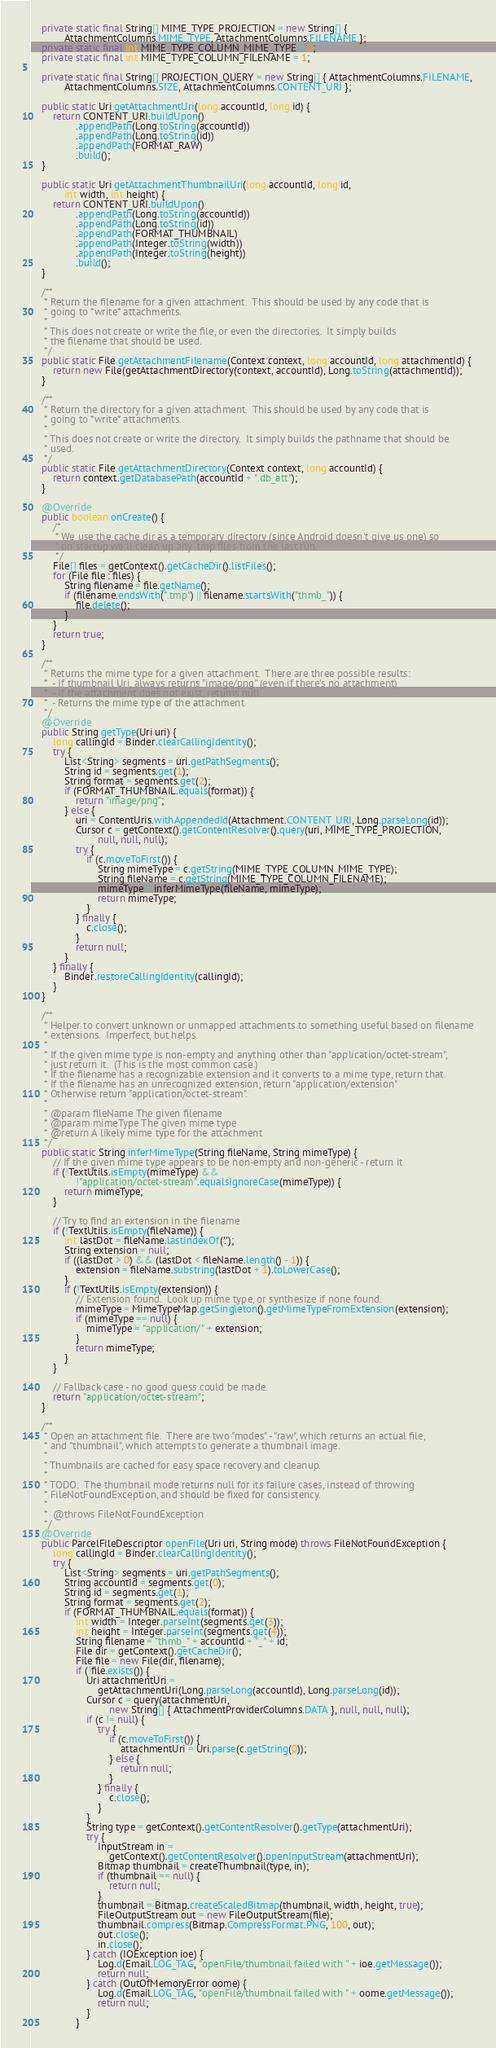<code> <loc_0><loc_0><loc_500><loc_500><_Java_>
    private static final String[] MIME_TYPE_PROJECTION = new String[] {
            AttachmentColumns.MIME_TYPE, AttachmentColumns.FILENAME };
    private static final int MIME_TYPE_COLUMN_MIME_TYPE = 0;
    private static final int MIME_TYPE_COLUMN_FILENAME = 1;

    private static final String[] PROJECTION_QUERY = new String[] { AttachmentColumns.FILENAME,
            AttachmentColumns.SIZE, AttachmentColumns.CONTENT_URI };

    public static Uri getAttachmentUri(long accountId, long id) {
        return CONTENT_URI.buildUpon()
                .appendPath(Long.toString(accountId))
                .appendPath(Long.toString(id))
                .appendPath(FORMAT_RAW)
                .build();
    }

    public static Uri getAttachmentThumbnailUri(long accountId, long id,
            int width, int height) {
        return CONTENT_URI.buildUpon()
                .appendPath(Long.toString(accountId))
                .appendPath(Long.toString(id))
                .appendPath(FORMAT_THUMBNAIL)
                .appendPath(Integer.toString(width))
                .appendPath(Integer.toString(height))
                .build();
    }

    /**
     * Return the filename for a given attachment.  This should be used by any code that is
     * going to *write* attachments.
     *
     * This does not create or write the file, or even the directories.  It simply builds
     * the filename that should be used.
     */
    public static File getAttachmentFilename(Context context, long accountId, long attachmentId) {
        return new File(getAttachmentDirectory(context, accountId), Long.toString(attachmentId));
    }

    /**
     * Return the directory for a given attachment.  This should be used by any code that is
     * going to *write* attachments.
     *
     * This does not create or write the directory.  It simply builds the pathname that should be
     * used.
     */
    public static File getAttachmentDirectory(Context context, long accountId) {
        return context.getDatabasePath(accountId + ".db_att");
    }

    @Override
    public boolean onCreate() {
        /*
         * We use the cache dir as a temporary directory (since Android doesn't give us one) so
         * on startup we'll clean up any .tmp files from the last run.
         */
        File[] files = getContext().getCacheDir().listFiles();
        for (File file : files) {
            String filename = file.getName();
            if (filename.endsWith(".tmp") || filename.startsWith("thmb_")) {
                file.delete();
            }
        }
        return true;
    }

    /**
     * Returns the mime type for a given attachment.  There are three possible results:
     *  - If thumbnail Uri, always returns "image/png" (even if there's no attachment)
     *  - If the attachment does not exist, returns null
     *  - Returns the mime type of the attachment
     */
    @Override
    public String getType(Uri uri) {
        long callingId = Binder.clearCallingIdentity();
        try {
            List<String> segments = uri.getPathSegments();
            String id = segments.get(1);
            String format = segments.get(2);
            if (FORMAT_THUMBNAIL.equals(format)) {
                return "image/png";
            } else {
                uri = ContentUris.withAppendedId(Attachment.CONTENT_URI, Long.parseLong(id));
                Cursor c = getContext().getContentResolver().query(uri, MIME_TYPE_PROJECTION,
                        null, null, null);
                try {
                    if (c.moveToFirst()) {
                        String mimeType = c.getString(MIME_TYPE_COLUMN_MIME_TYPE);
                        String fileName = c.getString(MIME_TYPE_COLUMN_FILENAME);
                        mimeType = inferMimeType(fileName, mimeType);
                        return mimeType;
                    }
                } finally {
                    c.close();
                }
                return null;
            }
        } finally {
            Binder.restoreCallingIdentity(callingId);
        }
    }

    /**
     * Helper to convert unknown or unmapped attachments to something useful based on filename
     * extensions.  Imperfect, but helps.
     *
     * If the given mime type is non-empty and anything other than "application/octet-stream",
     * just return it.  (This is the most common case.)
     * If the filename has a recognizable extension and it converts to a mime type, return that.
     * If the filename has an unrecognized extension, return "application/extension"
     * Otherwise return "application/octet-stream".
     *
     * @param fileName The given filename
     * @param mimeType The given mime type
     * @return A likely mime type for the attachment
     */
    public static String inferMimeType(String fileName, String mimeType) {
        // If the given mime type appears to be non-empty and non-generic - return it
        if (!TextUtils.isEmpty(mimeType) &&
                !"application/octet-stream".equalsIgnoreCase(mimeType)) {
            return mimeType;
        }

        // Try to find an extension in the filename
        if (!TextUtils.isEmpty(fileName)) {
            int lastDot = fileName.lastIndexOf('.');
            String extension = null;
            if ((lastDot > 0) && (lastDot < fileName.length() - 1)) {
                extension = fileName.substring(lastDot + 1).toLowerCase();
            }
            if (!TextUtils.isEmpty(extension)) {
                // Extension found.  Look up mime type, or synthesize if none found.
                mimeType = MimeTypeMap.getSingleton().getMimeTypeFromExtension(extension);
                if (mimeType == null) {
                    mimeType = "application/" + extension;
                }
                return mimeType;
            }
        }

        // Fallback case - no good guess could be made.
        return "application/octet-stream";
    }

    /**
     * Open an attachment file.  There are two "modes" - "raw", which returns an actual file,
     * and "thumbnail", which attempts to generate a thumbnail image.
     * 
     * Thumbnails are cached for easy space recovery and cleanup.
     * 
     * TODO:  The thumbnail mode returns null for its failure cases, instead of throwing
     * FileNotFoundException, and should be fixed for consistency.
     * 
     *  @throws FileNotFoundException
     */
    @Override
    public ParcelFileDescriptor openFile(Uri uri, String mode) throws FileNotFoundException {
        long callingId = Binder.clearCallingIdentity();
        try {
            List<String> segments = uri.getPathSegments();
            String accountId = segments.get(0);
            String id = segments.get(1);
            String format = segments.get(2);
            if (FORMAT_THUMBNAIL.equals(format)) {
                int width = Integer.parseInt(segments.get(3));
                int height = Integer.parseInt(segments.get(4));
                String filename = "thmb_" + accountId + "_" + id;
                File dir = getContext().getCacheDir();
                File file = new File(dir, filename);
                if (!file.exists()) {
                    Uri attachmentUri =
                        getAttachmentUri(Long.parseLong(accountId), Long.parseLong(id));
                    Cursor c = query(attachmentUri,
                            new String[] { AttachmentProviderColumns.DATA }, null, null, null);
                    if (c != null) {
                        try {
                            if (c.moveToFirst()) {
                                attachmentUri = Uri.parse(c.getString(0));
                            } else {
                                return null;
                            }
                        } finally {
                            c.close();
                        }
                    }
                    String type = getContext().getContentResolver().getType(attachmentUri);
                    try {
                        InputStream in =
                            getContext().getContentResolver().openInputStream(attachmentUri);
                        Bitmap thumbnail = createThumbnail(type, in);
                        if (thumbnail == null) {
                            return null;
                        }
                        thumbnail = Bitmap.createScaledBitmap(thumbnail, width, height, true);
                        FileOutputStream out = new FileOutputStream(file);
                        thumbnail.compress(Bitmap.CompressFormat.PNG, 100, out);
                        out.close();
                        in.close();
                    } catch (IOException ioe) {
                        Log.d(Email.LOG_TAG, "openFile/thumbnail failed with " + ioe.getMessage());
                        return null;
                    } catch (OutOfMemoryError oome) {
                        Log.d(Email.LOG_TAG, "openFile/thumbnail failed with " + oome.getMessage());
                        return null;
                    }
                }</code> 